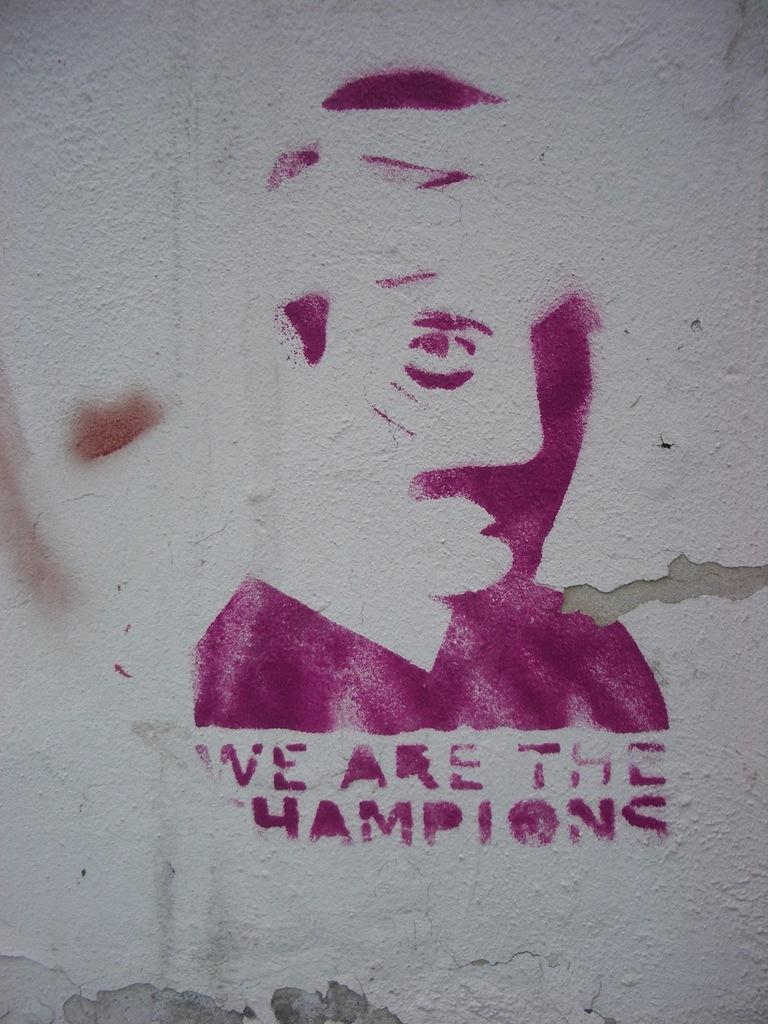What is on the wall in the image? There is a painting and text on the wall in the image. Can you describe the painting on the wall? Unfortunately, the facts provided do not give any details about the painting. What does the text on the wall say? The facts provided do not give any information about the content of the text on the wall. What type of animal can be seen in the fog in the image? There is no fog or animal present in the image. How many plantation workers are visible in the image? There is no reference to a plantation or workers in the image. 